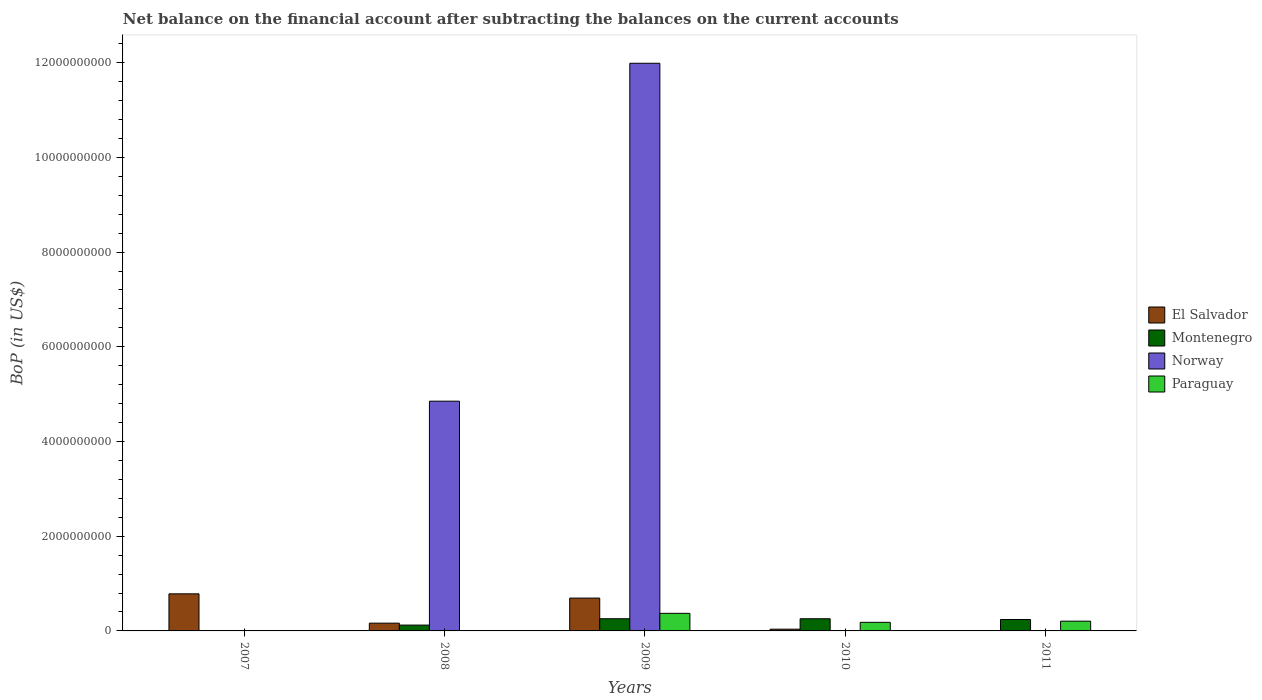How many different coloured bars are there?
Your response must be concise. 4. Are the number of bars on each tick of the X-axis equal?
Provide a succinct answer. No. How many bars are there on the 4th tick from the left?
Provide a succinct answer. 3. How many bars are there on the 4th tick from the right?
Give a very brief answer. 3. What is the Balance of Payments in Montenegro in 2010?
Provide a short and direct response. 2.57e+08. Across all years, what is the maximum Balance of Payments in Norway?
Your answer should be very brief. 1.20e+1. Across all years, what is the minimum Balance of Payments in Paraguay?
Your answer should be compact. 0. What is the total Balance of Payments in El Salvador in the graph?
Provide a short and direct response. 1.68e+09. What is the difference between the Balance of Payments in Paraguay in 2009 and that in 2011?
Provide a succinct answer. 1.65e+08. What is the difference between the Balance of Payments in El Salvador in 2007 and the Balance of Payments in Montenegro in 2008?
Provide a short and direct response. 6.60e+08. What is the average Balance of Payments in El Salvador per year?
Provide a short and direct response. 3.35e+08. In the year 2009, what is the difference between the Balance of Payments in El Salvador and Balance of Payments in Montenegro?
Your response must be concise. 4.36e+08. In how many years, is the Balance of Payments in Montenegro greater than 2800000000 US$?
Provide a succinct answer. 0. What is the ratio of the Balance of Payments in Montenegro in 2008 to that in 2010?
Keep it short and to the point. 0.48. What is the difference between the highest and the second highest Balance of Payments in Montenegro?
Your response must be concise. 3.79e+05. What is the difference between the highest and the lowest Balance of Payments in El Salvador?
Make the answer very short. 7.83e+08. Is the sum of the Balance of Payments in El Salvador in 2008 and 2009 greater than the maximum Balance of Payments in Paraguay across all years?
Keep it short and to the point. Yes. Is it the case that in every year, the sum of the Balance of Payments in Montenegro and Balance of Payments in El Salvador is greater than the sum of Balance of Payments in Paraguay and Balance of Payments in Norway?
Make the answer very short. No. Is it the case that in every year, the sum of the Balance of Payments in Paraguay and Balance of Payments in Norway is greater than the Balance of Payments in Montenegro?
Offer a terse response. No. Are the values on the major ticks of Y-axis written in scientific E-notation?
Provide a succinct answer. No. Does the graph contain grids?
Offer a terse response. No. How many legend labels are there?
Give a very brief answer. 4. What is the title of the graph?
Your answer should be very brief. Net balance on the financial account after subtracting the balances on the current accounts. What is the label or title of the X-axis?
Make the answer very short. Years. What is the label or title of the Y-axis?
Make the answer very short. BoP (in US$). What is the BoP (in US$) of El Salvador in 2007?
Your answer should be compact. 7.83e+08. What is the BoP (in US$) of Montenegro in 2007?
Your answer should be compact. 0. What is the BoP (in US$) of Paraguay in 2007?
Give a very brief answer. 0. What is the BoP (in US$) in El Salvador in 2008?
Offer a terse response. 1.64e+08. What is the BoP (in US$) of Montenegro in 2008?
Provide a short and direct response. 1.23e+08. What is the BoP (in US$) of Norway in 2008?
Offer a terse response. 4.85e+09. What is the BoP (in US$) in El Salvador in 2009?
Offer a very short reply. 6.93e+08. What is the BoP (in US$) in Montenegro in 2009?
Make the answer very short. 2.57e+08. What is the BoP (in US$) of Norway in 2009?
Offer a very short reply. 1.20e+1. What is the BoP (in US$) in Paraguay in 2009?
Provide a short and direct response. 3.71e+08. What is the BoP (in US$) in El Salvador in 2010?
Give a very brief answer. 3.69e+07. What is the BoP (in US$) in Montenegro in 2010?
Provide a short and direct response. 2.57e+08. What is the BoP (in US$) in Paraguay in 2010?
Your answer should be compact. 1.82e+08. What is the BoP (in US$) of El Salvador in 2011?
Your answer should be very brief. 0. What is the BoP (in US$) of Montenegro in 2011?
Provide a succinct answer. 2.41e+08. What is the BoP (in US$) in Norway in 2011?
Ensure brevity in your answer.  0. What is the BoP (in US$) in Paraguay in 2011?
Offer a terse response. 2.06e+08. Across all years, what is the maximum BoP (in US$) of El Salvador?
Offer a very short reply. 7.83e+08. Across all years, what is the maximum BoP (in US$) of Montenegro?
Keep it short and to the point. 2.57e+08. Across all years, what is the maximum BoP (in US$) of Norway?
Provide a succinct answer. 1.20e+1. Across all years, what is the maximum BoP (in US$) of Paraguay?
Provide a short and direct response. 3.71e+08. Across all years, what is the minimum BoP (in US$) of Montenegro?
Make the answer very short. 0. What is the total BoP (in US$) of El Salvador in the graph?
Your answer should be compact. 1.68e+09. What is the total BoP (in US$) in Montenegro in the graph?
Make the answer very short. 8.78e+08. What is the total BoP (in US$) in Norway in the graph?
Provide a succinct answer. 1.68e+1. What is the total BoP (in US$) of Paraguay in the graph?
Offer a very short reply. 7.59e+08. What is the difference between the BoP (in US$) in El Salvador in 2007 and that in 2008?
Give a very brief answer. 6.19e+08. What is the difference between the BoP (in US$) in El Salvador in 2007 and that in 2009?
Offer a terse response. 8.99e+07. What is the difference between the BoP (in US$) of El Salvador in 2007 and that in 2010?
Provide a succinct answer. 7.46e+08. What is the difference between the BoP (in US$) of El Salvador in 2008 and that in 2009?
Offer a terse response. -5.29e+08. What is the difference between the BoP (in US$) of Montenegro in 2008 and that in 2009?
Offer a very short reply. -1.34e+08. What is the difference between the BoP (in US$) of Norway in 2008 and that in 2009?
Offer a very short reply. -7.14e+09. What is the difference between the BoP (in US$) of El Salvador in 2008 and that in 2010?
Keep it short and to the point. 1.27e+08. What is the difference between the BoP (in US$) in Montenegro in 2008 and that in 2010?
Provide a short and direct response. -1.34e+08. What is the difference between the BoP (in US$) in Montenegro in 2008 and that in 2011?
Make the answer very short. -1.18e+08. What is the difference between the BoP (in US$) in El Salvador in 2009 and that in 2010?
Your answer should be very brief. 6.56e+08. What is the difference between the BoP (in US$) in Montenegro in 2009 and that in 2010?
Keep it short and to the point. 3.79e+05. What is the difference between the BoP (in US$) of Paraguay in 2009 and that in 2010?
Make the answer very short. 1.90e+08. What is the difference between the BoP (in US$) of Montenegro in 2009 and that in 2011?
Make the answer very short. 1.61e+07. What is the difference between the BoP (in US$) of Paraguay in 2009 and that in 2011?
Ensure brevity in your answer.  1.65e+08. What is the difference between the BoP (in US$) in Montenegro in 2010 and that in 2011?
Offer a very short reply. 1.58e+07. What is the difference between the BoP (in US$) of Paraguay in 2010 and that in 2011?
Give a very brief answer. -2.46e+07. What is the difference between the BoP (in US$) in El Salvador in 2007 and the BoP (in US$) in Montenegro in 2008?
Your answer should be compact. 6.60e+08. What is the difference between the BoP (in US$) in El Salvador in 2007 and the BoP (in US$) in Norway in 2008?
Your answer should be compact. -4.07e+09. What is the difference between the BoP (in US$) in El Salvador in 2007 and the BoP (in US$) in Montenegro in 2009?
Give a very brief answer. 5.26e+08. What is the difference between the BoP (in US$) in El Salvador in 2007 and the BoP (in US$) in Norway in 2009?
Your answer should be compact. -1.12e+1. What is the difference between the BoP (in US$) in El Salvador in 2007 and the BoP (in US$) in Paraguay in 2009?
Offer a very short reply. 4.12e+08. What is the difference between the BoP (in US$) in El Salvador in 2007 and the BoP (in US$) in Montenegro in 2010?
Your answer should be compact. 5.26e+08. What is the difference between the BoP (in US$) of El Salvador in 2007 and the BoP (in US$) of Paraguay in 2010?
Keep it short and to the point. 6.02e+08. What is the difference between the BoP (in US$) of El Salvador in 2007 and the BoP (in US$) of Montenegro in 2011?
Give a very brief answer. 5.42e+08. What is the difference between the BoP (in US$) of El Salvador in 2007 and the BoP (in US$) of Paraguay in 2011?
Provide a succinct answer. 5.77e+08. What is the difference between the BoP (in US$) of El Salvador in 2008 and the BoP (in US$) of Montenegro in 2009?
Keep it short and to the point. -9.33e+07. What is the difference between the BoP (in US$) in El Salvador in 2008 and the BoP (in US$) in Norway in 2009?
Give a very brief answer. -1.18e+1. What is the difference between the BoP (in US$) of El Salvador in 2008 and the BoP (in US$) of Paraguay in 2009?
Your answer should be very brief. -2.07e+08. What is the difference between the BoP (in US$) in Montenegro in 2008 and the BoP (in US$) in Norway in 2009?
Offer a very short reply. -1.19e+1. What is the difference between the BoP (in US$) in Montenegro in 2008 and the BoP (in US$) in Paraguay in 2009?
Your response must be concise. -2.48e+08. What is the difference between the BoP (in US$) of Norway in 2008 and the BoP (in US$) of Paraguay in 2009?
Your answer should be compact. 4.48e+09. What is the difference between the BoP (in US$) in El Salvador in 2008 and the BoP (in US$) in Montenegro in 2010?
Offer a terse response. -9.29e+07. What is the difference between the BoP (in US$) of El Salvador in 2008 and the BoP (in US$) of Paraguay in 2010?
Your response must be concise. -1.76e+07. What is the difference between the BoP (in US$) in Montenegro in 2008 and the BoP (in US$) in Paraguay in 2010?
Offer a very short reply. -5.84e+07. What is the difference between the BoP (in US$) of Norway in 2008 and the BoP (in US$) of Paraguay in 2010?
Offer a terse response. 4.67e+09. What is the difference between the BoP (in US$) in El Salvador in 2008 and the BoP (in US$) in Montenegro in 2011?
Give a very brief answer. -7.71e+07. What is the difference between the BoP (in US$) of El Salvador in 2008 and the BoP (in US$) of Paraguay in 2011?
Make the answer very short. -4.22e+07. What is the difference between the BoP (in US$) in Montenegro in 2008 and the BoP (in US$) in Paraguay in 2011?
Make the answer very short. -8.30e+07. What is the difference between the BoP (in US$) in Norway in 2008 and the BoP (in US$) in Paraguay in 2011?
Provide a succinct answer. 4.65e+09. What is the difference between the BoP (in US$) in El Salvador in 2009 and the BoP (in US$) in Montenegro in 2010?
Your response must be concise. 4.36e+08. What is the difference between the BoP (in US$) of El Salvador in 2009 and the BoP (in US$) of Paraguay in 2010?
Give a very brief answer. 5.12e+08. What is the difference between the BoP (in US$) in Montenegro in 2009 and the BoP (in US$) in Paraguay in 2010?
Offer a terse response. 7.57e+07. What is the difference between the BoP (in US$) of Norway in 2009 and the BoP (in US$) of Paraguay in 2010?
Offer a very short reply. 1.18e+1. What is the difference between the BoP (in US$) of El Salvador in 2009 and the BoP (in US$) of Montenegro in 2011?
Offer a terse response. 4.52e+08. What is the difference between the BoP (in US$) in El Salvador in 2009 and the BoP (in US$) in Paraguay in 2011?
Give a very brief answer. 4.87e+08. What is the difference between the BoP (in US$) of Montenegro in 2009 and the BoP (in US$) of Paraguay in 2011?
Keep it short and to the point. 5.11e+07. What is the difference between the BoP (in US$) in Norway in 2009 and the BoP (in US$) in Paraguay in 2011?
Provide a short and direct response. 1.18e+1. What is the difference between the BoP (in US$) of El Salvador in 2010 and the BoP (in US$) of Montenegro in 2011?
Offer a very short reply. -2.04e+08. What is the difference between the BoP (in US$) in El Salvador in 2010 and the BoP (in US$) in Paraguay in 2011?
Your answer should be compact. -1.69e+08. What is the difference between the BoP (in US$) of Montenegro in 2010 and the BoP (in US$) of Paraguay in 2011?
Provide a succinct answer. 5.07e+07. What is the average BoP (in US$) in El Salvador per year?
Provide a short and direct response. 3.35e+08. What is the average BoP (in US$) in Montenegro per year?
Give a very brief answer. 1.76e+08. What is the average BoP (in US$) of Norway per year?
Provide a succinct answer. 3.37e+09. What is the average BoP (in US$) in Paraguay per year?
Ensure brevity in your answer.  1.52e+08. In the year 2008, what is the difference between the BoP (in US$) in El Salvador and BoP (in US$) in Montenegro?
Your answer should be very brief. 4.09e+07. In the year 2008, what is the difference between the BoP (in US$) of El Salvador and BoP (in US$) of Norway?
Ensure brevity in your answer.  -4.69e+09. In the year 2008, what is the difference between the BoP (in US$) in Montenegro and BoP (in US$) in Norway?
Your answer should be compact. -4.73e+09. In the year 2009, what is the difference between the BoP (in US$) of El Salvador and BoP (in US$) of Montenegro?
Offer a very short reply. 4.36e+08. In the year 2009, what is the difference between the BoP (in US$) of El Salvador and BoP (in US$) of Norway?
Give a very brief answer. -1.13e+1. In the year 2009, what is the difference between the BoP (in US$) in El Salvador and BoP (in US$) in Paraguay?
Offer a terse response. 3.22e+08. In the year 2009, what is the difference between the BoP (in US$) of Montenegro and BoP (in US$) of Norway?
Keep it short and to the point. -1.17e+1. In the year 2009, what is the difference between the BoP (in US$) of Montenegro and BoP (in US$) of Paraguay?
Keep it short and to the point. -1.14e+08. In the year 2009, what is the difference between the BoP (in US$) in Norway and BoP (in US$) in Paraguay?
Your answer should be compact. 1.16e+1. In the year 2010, what is the difference between the BoP (in US$) of El Salvador and BoP (in US$) of Montenegro?
Keep it short and to the point. -2.20e+08. In the year 2010, what is the difference between the BoP (in US$) in El Salvador and BoP (in US$) in Paraguay?
Provide a short and direct response. -1.45e+08. In the year 2010, what is the difference between the BoP (in US$) of Montenegro and BoP (in US$) of Paraguay?
Give a very brief answer. 7.53e+07. In the year 2011, what is the difference between the BoP (in US$) in Montenegro and BoP (in US$) in Paraguay?
Offer a terse response. 3.50e+07. What is the ratio of the BoP (in US$) of El Salvador in 2007 to that in 2008?
Make the answer very short. 4.78. What is the ratio of the BoP (in US$) of El Salvador in 2007 to that in 2009?
Keep it short and to the point. 1.13. What is the ratio of the BoP (in US$) of El Salvador in 2007 to that in 2010?
Your answer should be very brief. 21.22. What is the ratio of the BoP (in US$) of El Salvador in 2008 to that in 2009?
Your response must be concise. 0.24. What is the ratio of the BoP (in US$) of Montenegro in 2008 to that in 2009?
Your answer should be very brief. 0.48. What is the ratio of the BoP (in US$) of Norway in 2008 to that in 2009?
Your response must be concise. 0.4. What is the ratio of the BoP (in US$) in El Salvador in 2008 to that in 2010?
Provide a succinct answer. 4.44. What is the ratio of the BoP (in US$) of Montenegro in 2008 to that in 2010?
Give a very brief answer. 0.48. What is the ratio of the BoP (in US$) of Montenegro in 2008 to that in 2011?
Make the answer very short. 0.51. What is the ratio of the BoP (in US$) in El Salvador in 2009 to that in 2010?
Offer a very short reply. 18.78. What is the ratio of the BoP (in US$) of Paraguay in 2009 to that in 2010?
Your answer should be very brief. 2.05. What is the ratio of the BoP (in US$) in Montenegro in 2009 to that in 2011?
Make the answer very short. 1.07. What is the ratio of the BoP (in US$) of Paraguay in 2009 to that in 2011?
Offer a terse response. 1.8. What is the ratio of the BoP (in US$) of Montenegro in 2010 to that in 2011?
Your answer should be compact. 1.07. What is the ratio of the BoP (in US$) of Paraguay in 2010 to that in 2011?
Provide a succinct answer. 0.88. What is the difference between the highest and the second highest BoP (in US$) in El Salvador?
Your response must be concise. 8.99e+07. What is the difference between the highest and the second highest BoP (in US$) of Montenegro?
Your answer should be compact. 3.79e+05. What is the difference between the highest and the second highest BoP (in US$) in Paraguay?
Provide a succinct answer. 1.65e+08. What is the difference between the highest and the lowest BoP (in US$) of El Salvador?
Keep it short and to the point. 7.83e+08. What is the difference between the highest and the lowest BoP (in US$) in Montenegro?
Your answer should be very brief. 2.57e+08. What is the difference between the highest and the lowest BoP (in US$) in Norway?
Make the answer very short. 1.20e+1. What is the difference between the highest and the lowest BoP (in US$) in Paraguay?
Your response must be concise. 3.71e+08. 